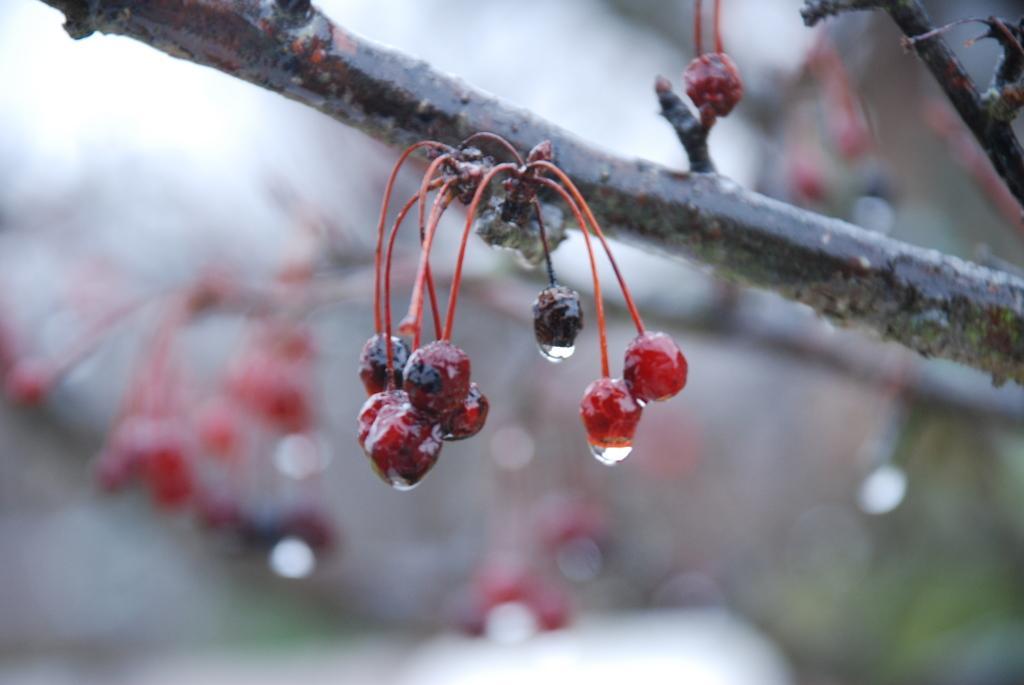How would you summarize this image in a sentence or two? In this image I can see some fruits to a stem. These fruits are in red and black colors. The background is blurred. 